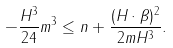Convert formula to latex. <formula><loc_0><loc_0><loc_500><loc_500>- \frac { H ^ { 3 } } { 2 4 } m ^ { 3 } \leq n + \frac { ( H \cdot \beta ) ^ { 2 } } { 2 m H ^ { 3 } } .</formula> 